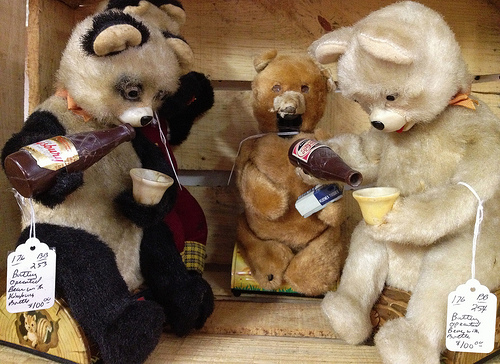<image>
Can you confirm if the bear is on the drink? No. The bear is not positioned on the drink. They may be near each other, but the bear is not supported by or resting on top of the drink. 